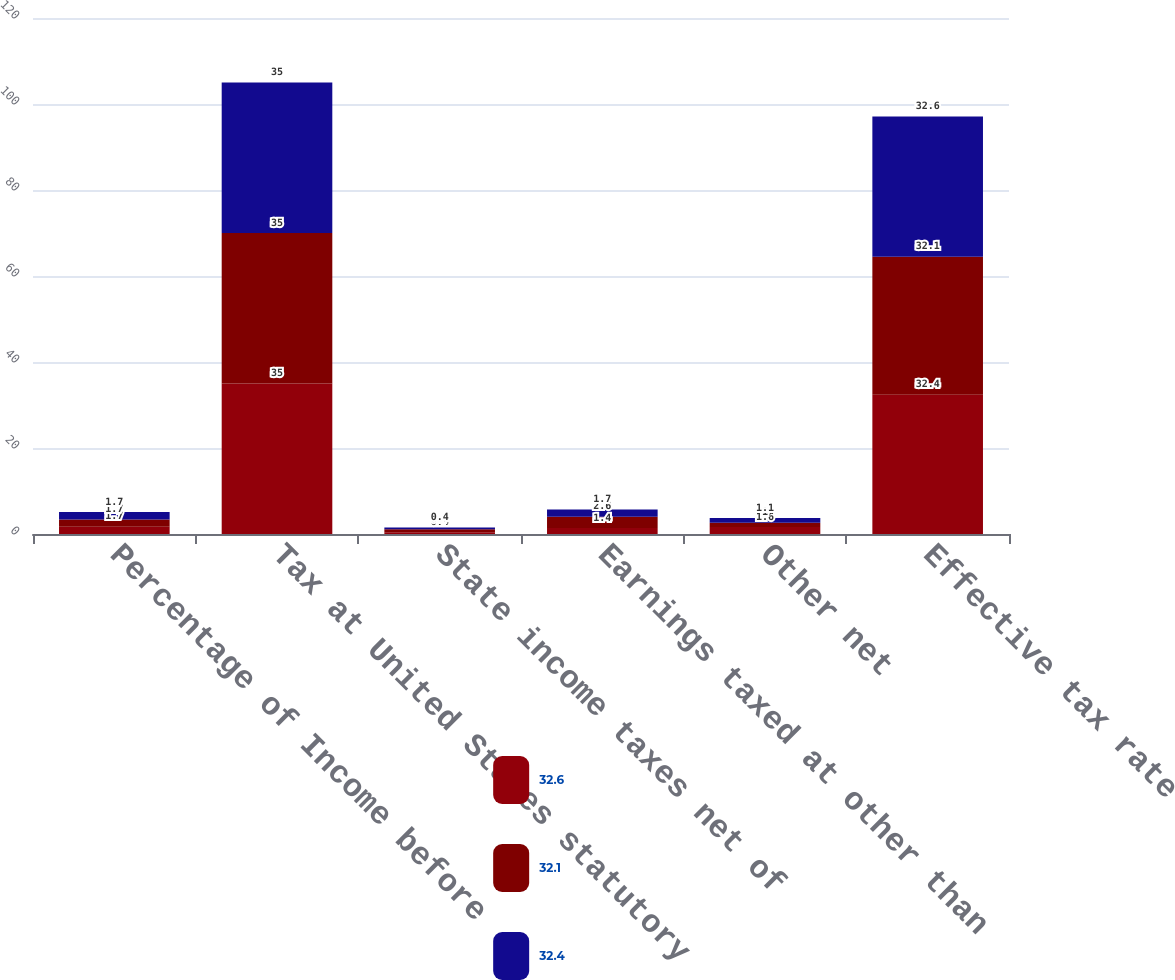Convert chart. <chart><loc_0><loc_0><loc_500><loc_500><stacked_bar_chart><ecel><fcel>Percentage of Income before<fcel>Tax at United States statutory<fcel>State income taxes net of<fcel>Earnings taxed at other than<fcel>Other net<fcel>Effective tax rate<nl><fcel>32.6<fcel>1.7<fcel>35<fcel>0.4<fcel>1.4<fcel>1.6<fcel>32.4<nl><fcel>32.1<fcel>1.7<fcel>35<fcel>0.7<fcel>2.6<fcel>1<fcel>32.1<nl><fcel>32.4<fcel>1.7<fcel>35<fcel>0.4<fcel>1.7<fcel>1.1<fcel>32.6<nl></chart> 